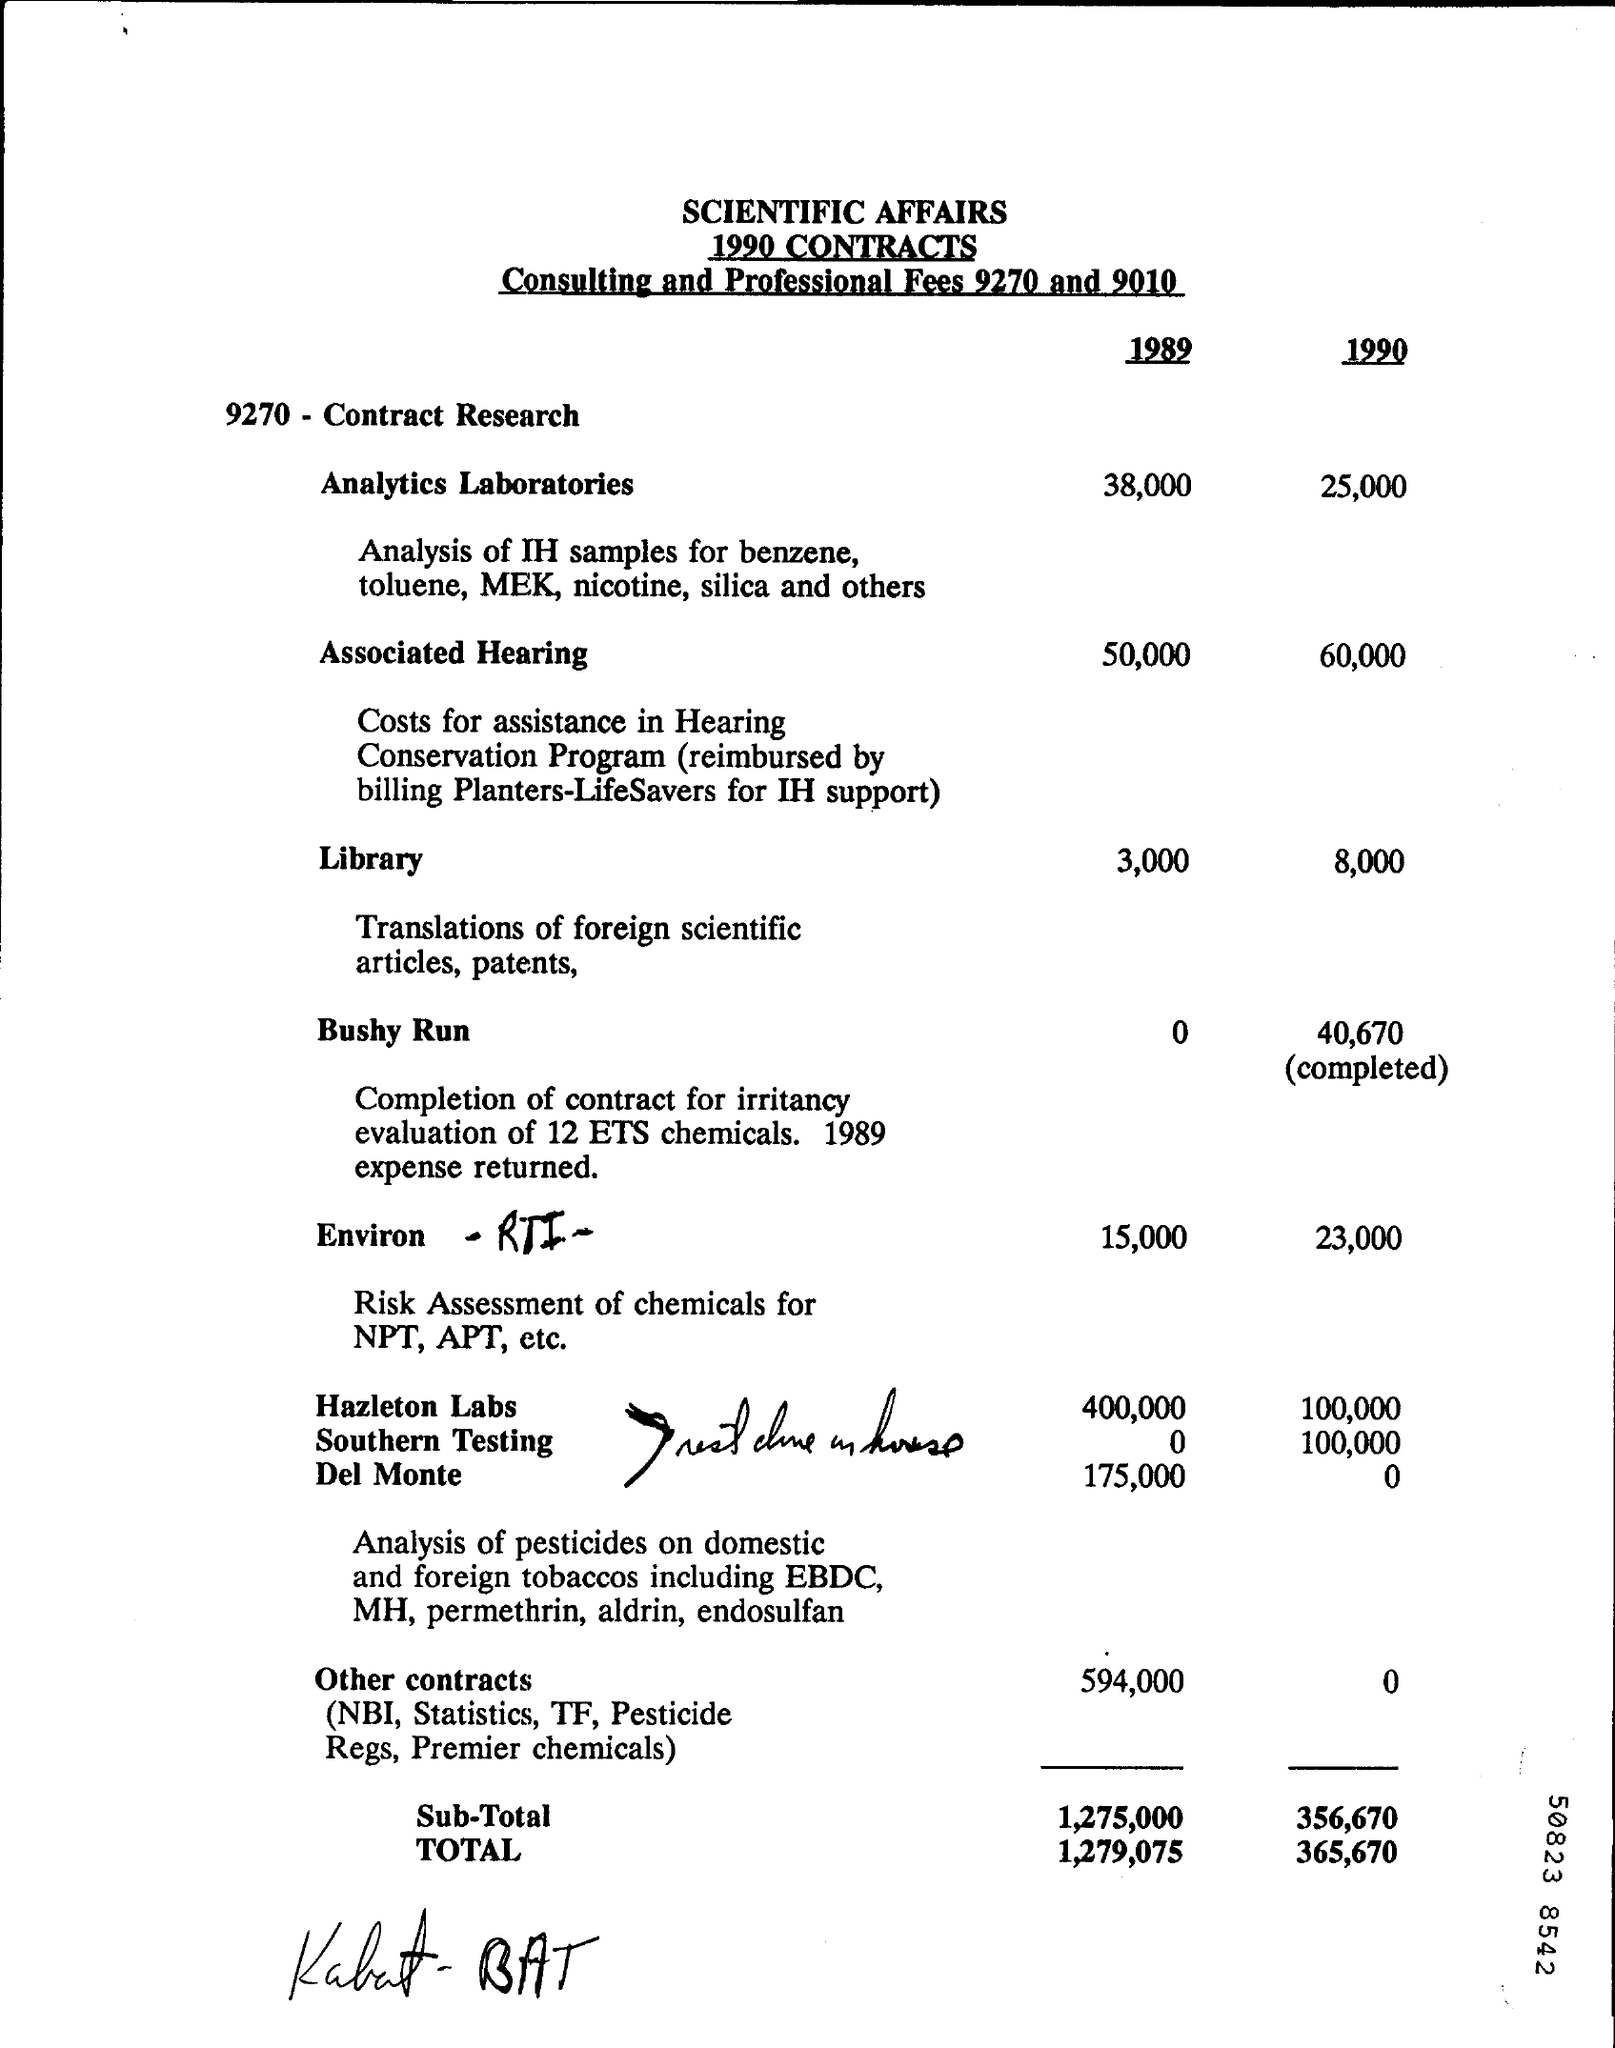What was the fee for analytics laboratories in 1989?
Offer a terse response. 38,000. What was the fee for analytics laboratories in 1990?
Provide a short and direct response. 25,000. What was the fee for Library in 1989?
Your answer should be compact. 3,000. What was the fee for Library in 1990 ?
Make the answer very short. 8,000. What was the Associated Hearing fee in 1989 ?
Keep it short and to the point. 50,000. What was the Associated Hearing fee in 1990 ?
Keep it short and to the point. 60,000. What was the total cost in 1989 ?
Your answer should be compact. 1,279,075. What was the total cost in 1990 ?
Give a very brief answer. 365,670. 